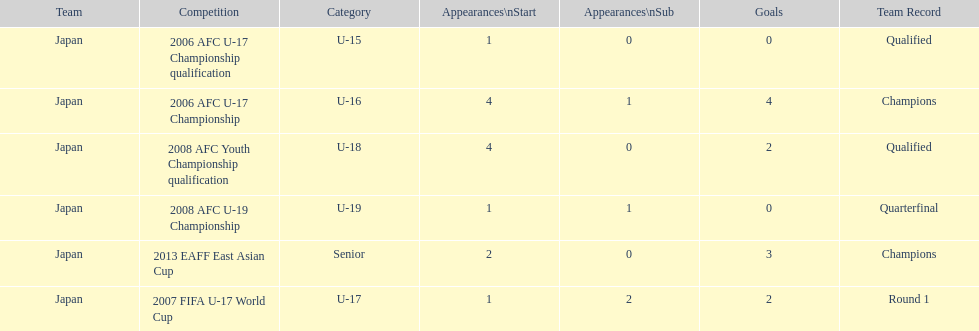Did japan have more starting appearances in the 2013 eaff east asian cup or 2007 fifa u-17 world cup? 2013 EAFF East Asian Cup. 